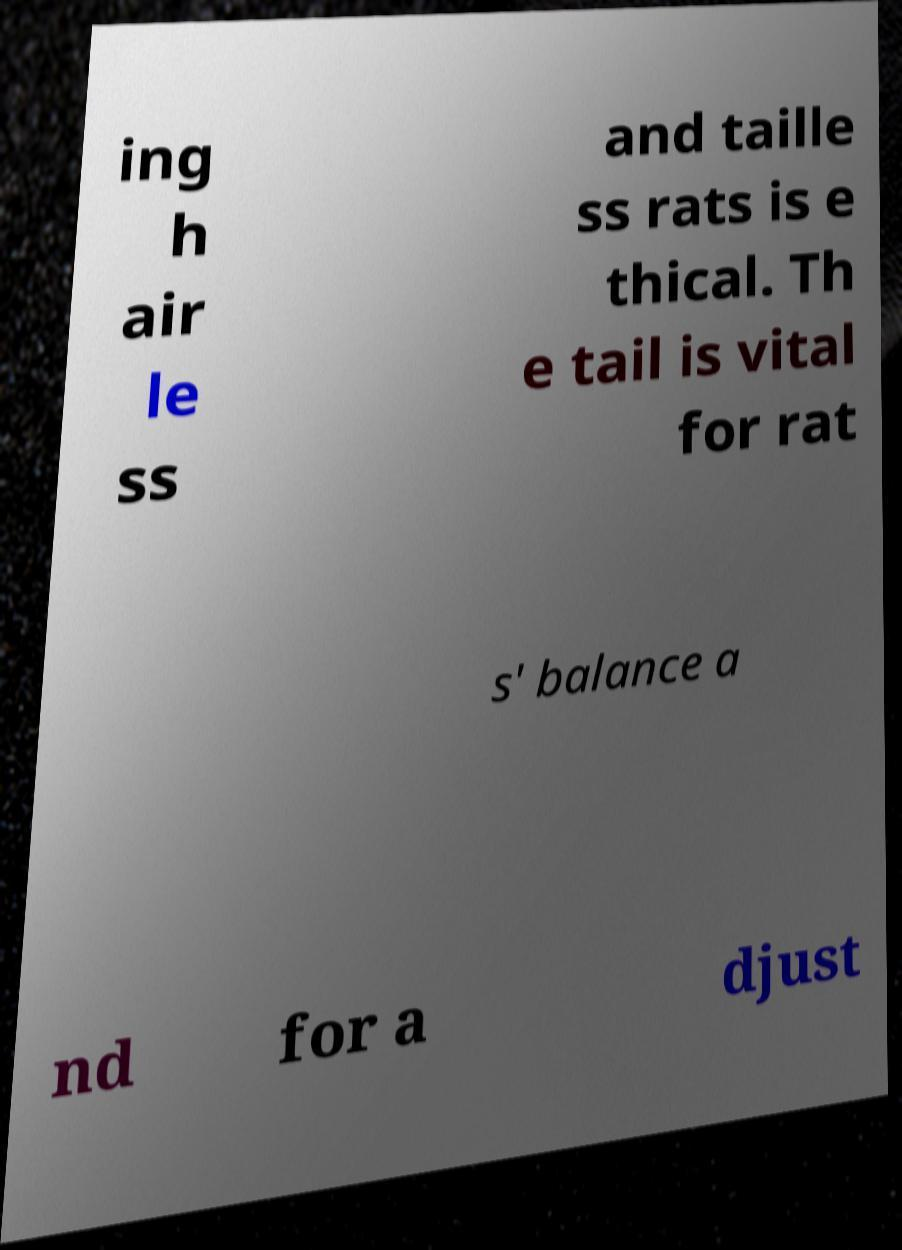Please identify and transcribe the text found in this image. ing h air le ss and taille ss rats is e thical. Th e tail is vital for rat s' balance a nd for a djust 